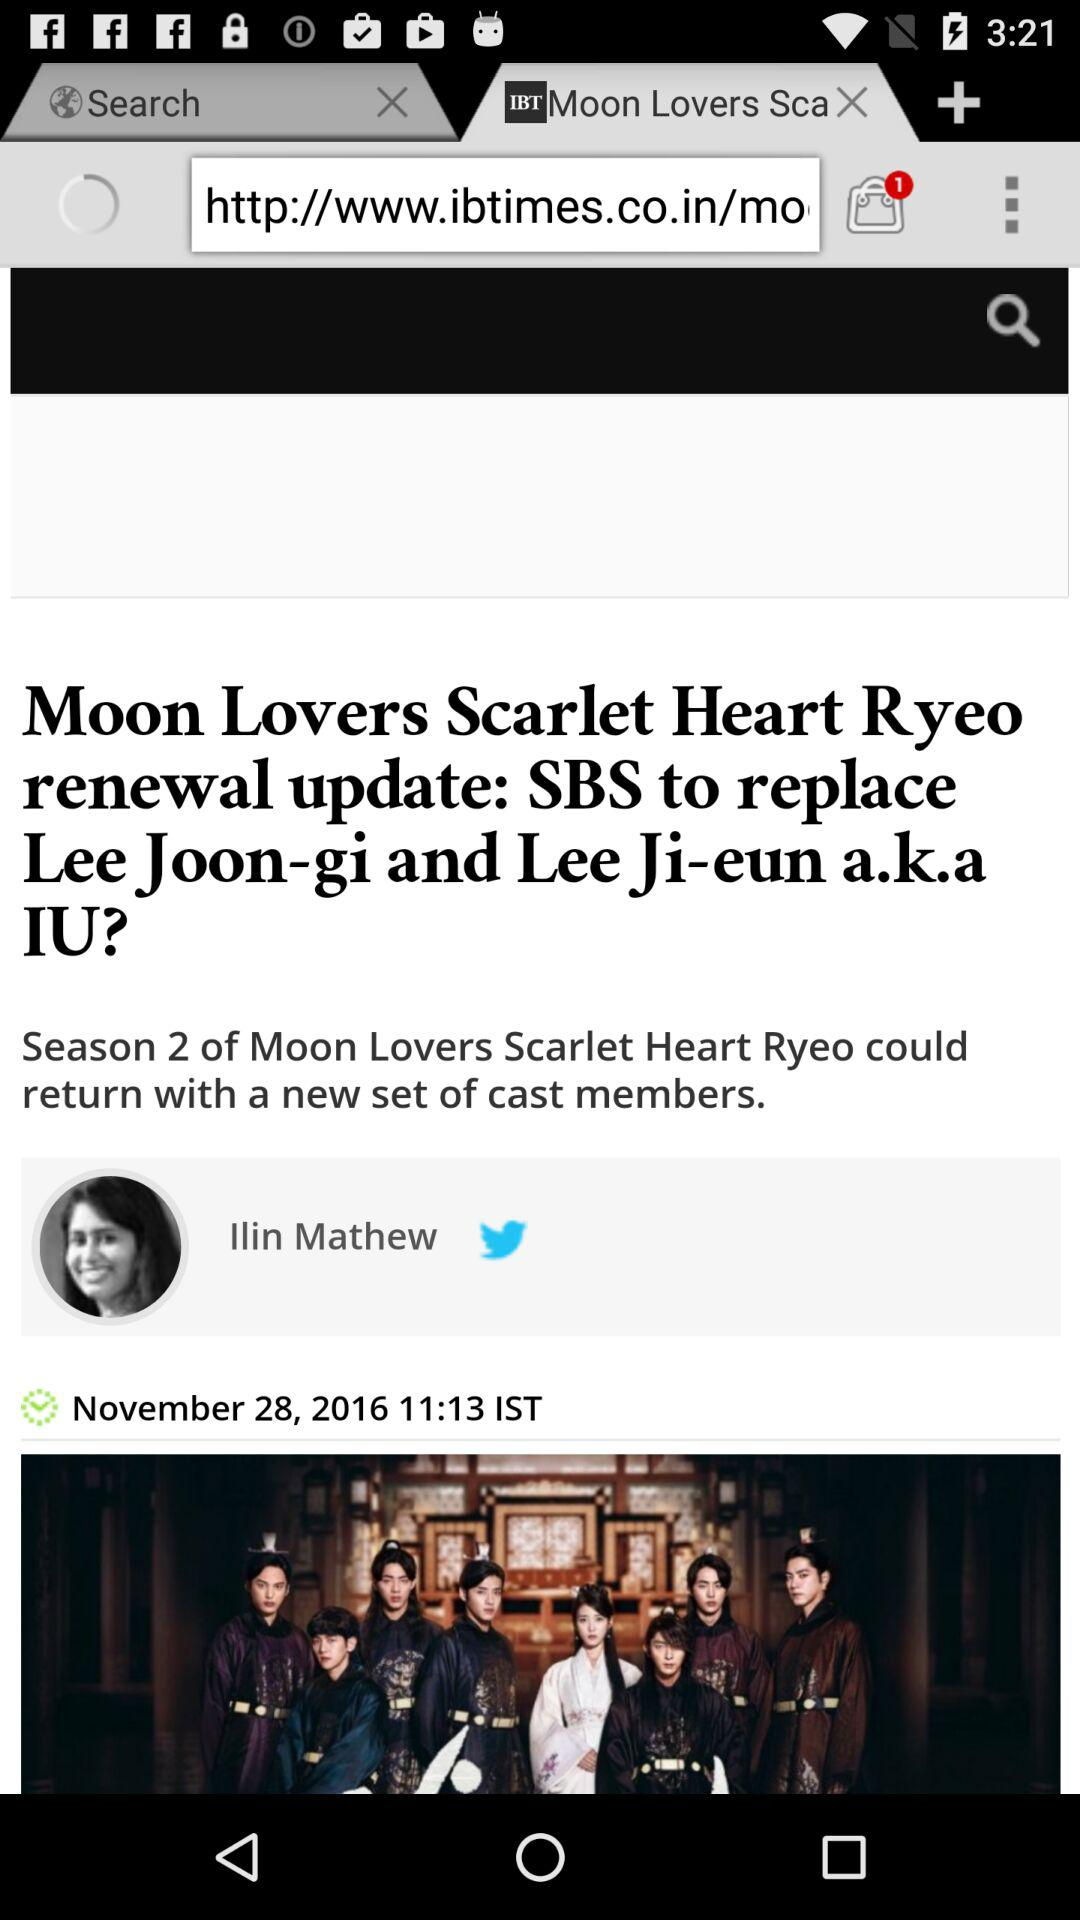How many notifications are pending? There is 1 notification pending. 